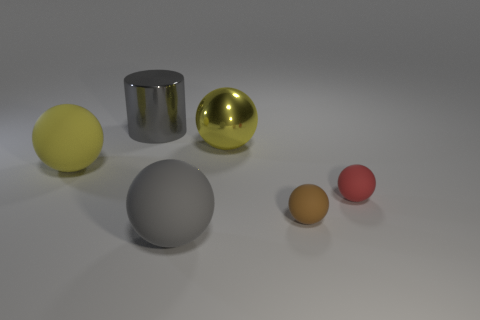Add 3 gray rubber things. How many objects exist? 9 Subtract all balls. How many objects are left? 1 Add 1 big gray metal objects. How many big gray metal objects are left? 2 Add 4 big gray objects. How many big gray objects exist? 6 Subtract 1 gray balls. How many objects are left? 5 Subtract all small purple shiny things. Subtract all gray cylinders. How many objects are left? 5 